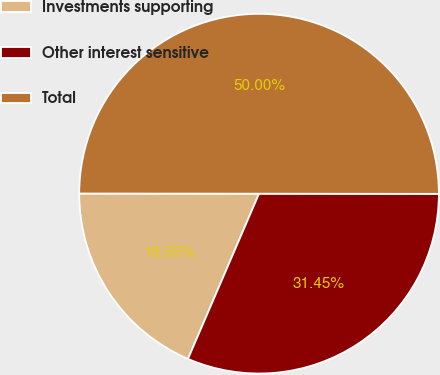Convert chart. <chart><loc_0><loc_0><loc_500><loc_500><pie_chart><fcel>Investments supporting<fcel>Other interest sensitive<fcel>Total<nl><fcel>18.55%<fcel>31.45%<fcel>50.0%<nl></chart> 